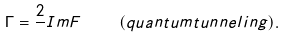Convert formula to latex. <formula><loc_0><loc_0><loc_500><loc_500>\Gamma = \frac { 2 } { } I m F \quad \ ( q u a n t u m t u n n e l i n g ) .</formula> 